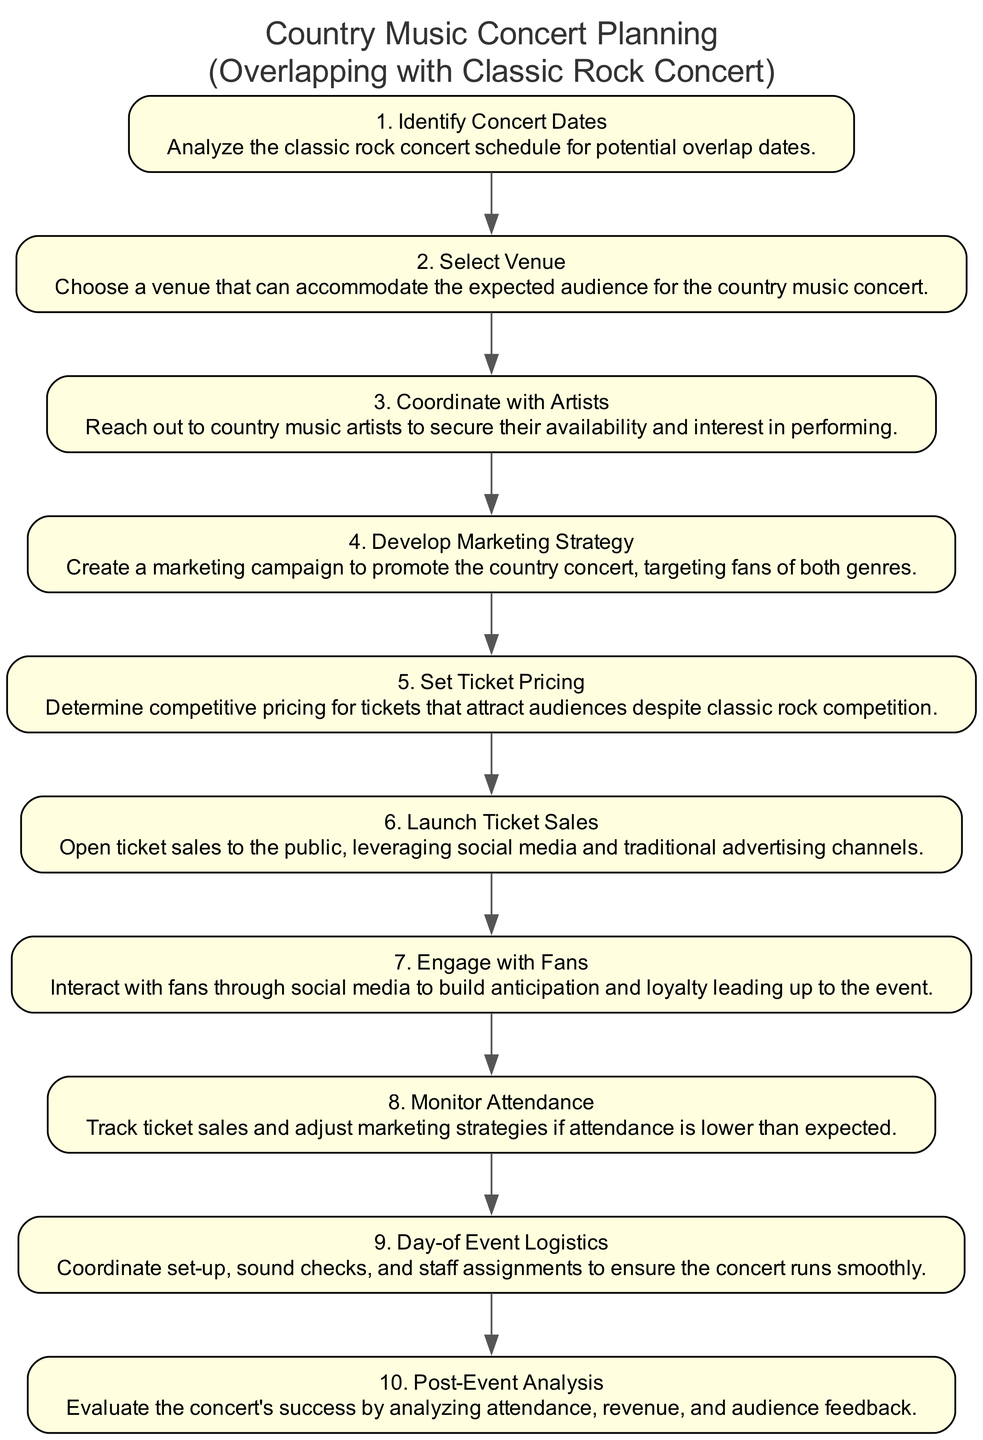What is the first step in the concert planning sequence? The first step listed in the diagram is "Identify Concert Dates," which involves analyzing the classic rock concert schedule for potential overlap dates.
Answer: Identify Concert Dates How many total steps are there in the sequence? By counting the nodes in the diagram, there are 10 steps in total related to planning the concert event.
Answer: 10 What is the last step in the planning sequence? The last step in the diagram is "Post-Event Analysis," which entails evaluating the concert's success by analyzing attendance, revenue, and audience feedback.
Answer: Post-Event Analysis Which step involves reaching out to artists? The step "Coordinate with Artists" specifies the action of contacting country music artists to secure their availability and interest in performing.
Answer: Coordinate with Artists What is the relationship between "Set Ticket Pricing" and "Launch Ticket Sales"? "Set Ticket Pricing" precedes "Launch Ticket Sales," meaning ticket pricing needs to be determined before the sales open to the public.
Answer: Precedes What step comes right after "Coordinate with Artists"? Following "Coordinate with Artists," the next step in the sequence is "Develop Marketing Strategy."
Answer: Develop Marketing Strategy Which step focuses on interaction with fans? The step "Engage with Fans" is dedicated to interacting with fans through social media to build anticipation and loyalty for the event.
Answer: Engage with Fans How does the process adjust if attendance is lower than expected? "Monitor Attendance" is the step that focuses on tracking ticket sales and adjusting marketing strategies in response to lower attendance.
Answer: Monitor Attendance What is the primary goal of the "Develop Marketing Strategy" step? The main goal of this step is to create a marketing campaign that promotes the country concert, specifically targeting fans of both country and classic rock genres.
Answer: Create a marketing campaign Which steps are directly related to the event's execution? The steps "Day-of Event Logistics" and "Post-Event Analysis" are directly related to the execution of the event, one ensuring smooth operations on the day of and the other analyzing the event's success afterward.
Answer: Day-of Event Logistics, Post-Event Analysis 